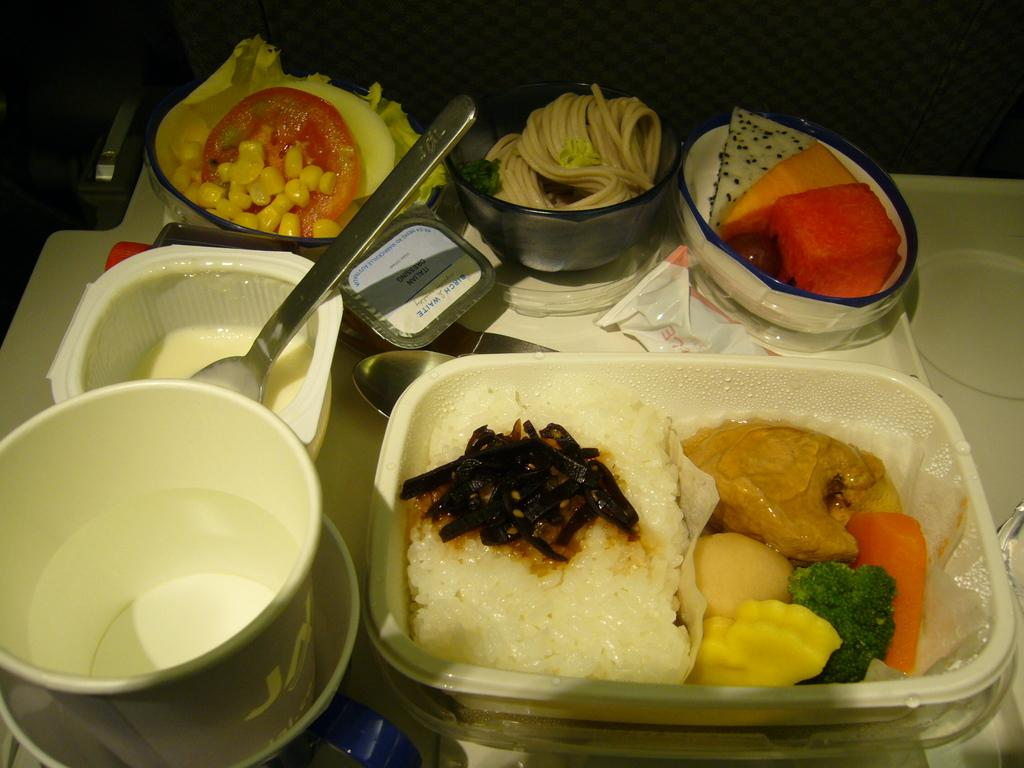What is the main object on the table in the image? There is a serving plate in the image. What can be found on the serving plate? The serving plate has different kinds of dishes in bowls. What might be used to eat the dishes on the serving plate? Cutlery is present in the image. What type of plantation can be seen in the background of the image? There is no plantation visible in the image; it only shows a serving plate with dishes and cutlery. 